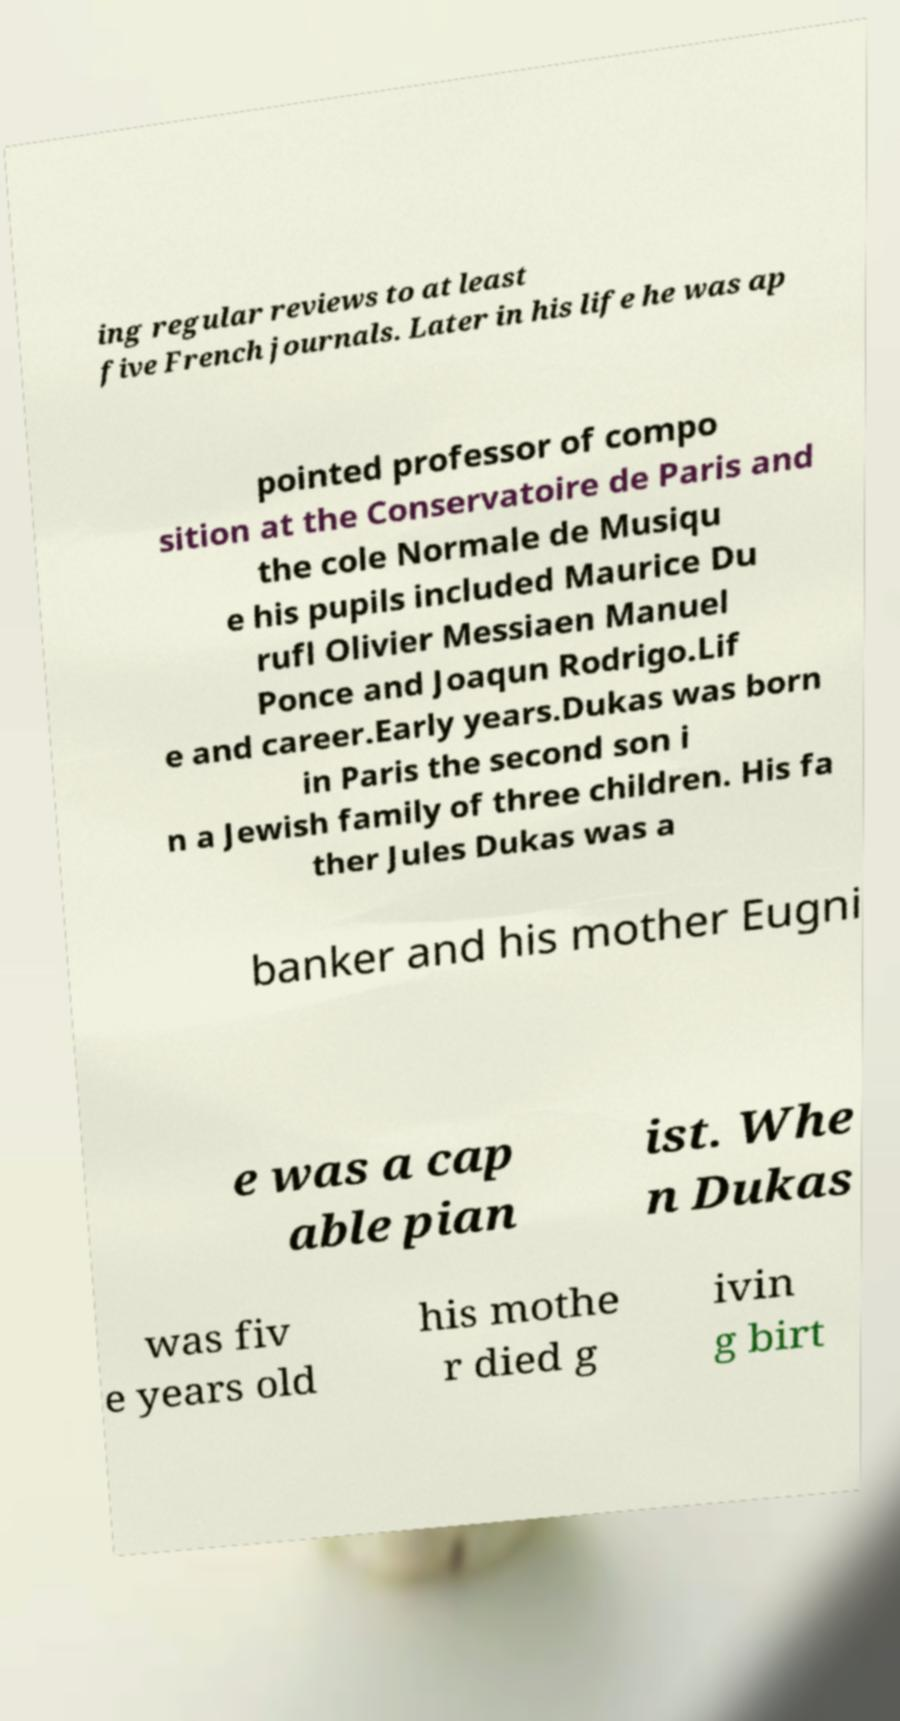Can you read and provide the text displayed in the image?This photo seems to have some interesting text. Can you extract and type it out for me? ing regular reviews to at least five French journals. Later in his life he was ap pointed professor of compo sition at the Conservatoire de Paris and the cole Normale de Musiqu e his pupils included Maurice Du rufl Olivier Messiaen Manuel Ponce and Joaqun Rodrigo.Lif e and career.Early years.Dukas was born in Paris the second son i n a Jewish family of three children. His fa ther Jules Dukas was a banker and his mother Eugni e was a cap able pian ist. Whe n Dukas was fiv e years old his mothe r died g ivin g birt 